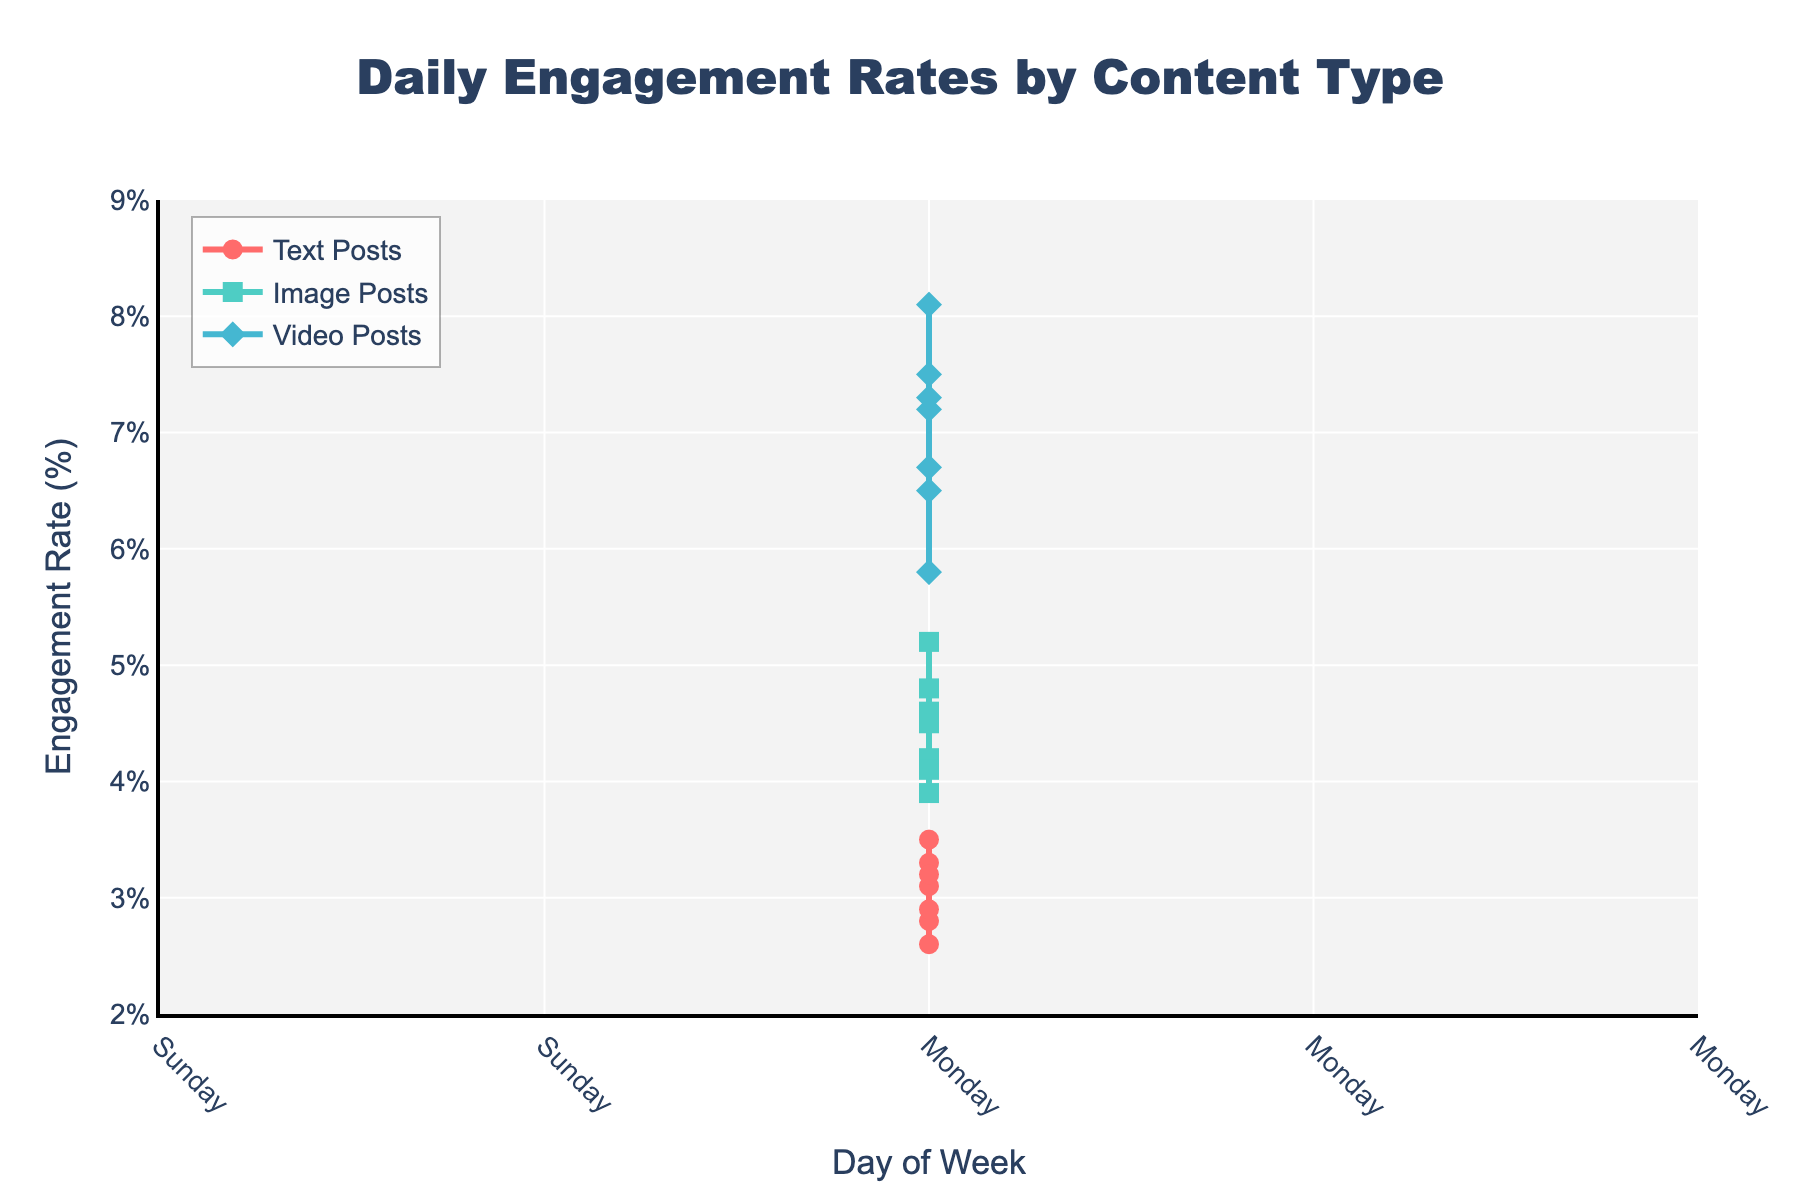What type of post has the highest engagement rate on Friday? By referring to the figure, we observe that Video Posts have the highest engagement rate on Friday, marked with a data point above the others.
Answer: Video Posts Which type of post consistently has the lowest daily engagement rate throughout the week? By visually assessing the lines over the week, Text Posts consistently have the lowest engagement rate every day.
Answer: Text Posts What's the difference in engagement rate between Image Posts and Video Posts on Sunday? On Sunday, Image Posts have a 4.6% engagement rate and Video Posts have a 7.3% rate. The difference is 7.3% - 4.6% = 2.7%.
Answer: 2.7% Which day has the greatest engagement for Image Posts and what is that rate? By examining the figure, the highest point for Image Posts occurs on Saturday with an engagement rate of 5.2%.
Answer: Saturday, 5.2% On which day does the engagement rate for Text Posts surpass 3% and for how many days does it stay above this threshold? From the figure, Text Posts exceed 3% on Wednesday (3.1%), Friday (3.3%), Saturday (3.5%), and Sunday (3.2%). This happens for 4 days.
Answer: Wednesday, Friday, Saturday, Sunday; 4 days Is there any day where Image Posts have a lower engagement rate than Text Posts? Reviewing the plotted lines, there is no day where Image Posts have lower engagement than Text Posts.
Answer: No Calculate the average engagement rate for Video Posts across the week. The engagement rates for Video Posts are: 6.5%, 5.8%, 7.2%, 6.7%, 7.5%, 8.1%, and 7.3%. Sum these and divide by 7: (6.5 + 5.8 + 7.2 + 6.7 + 7.5 + 8.1 + 7.3) / 7 ≈ 7.01%.
Answer: 7.01% Compare the initial and final engagement rates for Text Posts from Monday to Sunday. Do they increase or decrease? Text Posts start at 2.8% on Monday and end at 3.2% on Sunday. The engagement rate increases.
Answer: Increase How many days of the week do Image Posts have a higher engagement rate than Text Posts but lower than Video Posts? Checking the daily rates: Monday, Tuesday, Wednesday, Thursday, Sunday all fit this condition. So, it happens on 5 days.
Answer: 5 days 